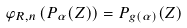Convert formula to latex. <formula><loc_0><loc_0><loc_500><loc_500>\varphi _ { R , n } \left ( P _ { \alpha } ( Z ) \right ) = P _ { g ( \alpha ) } ( Z )</formula> 